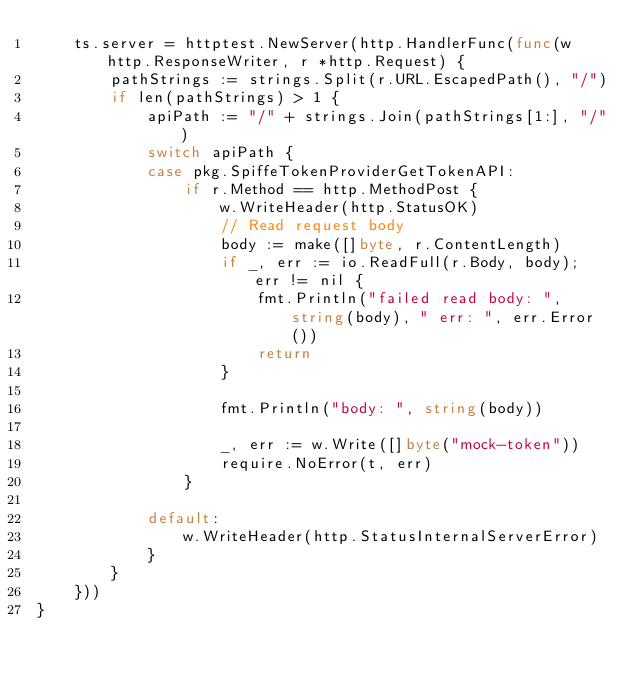<code> <loc_0><loc_0><loc_500><loc_500><_Go_>	ts.server = httptest.NewServer(http.HandlerFunc(func(w http.ResponseWriter, r *http.Request) {
		pathStrings := strings.Split(r.URL.EscapedPath(), "/")
		if len(pathStrings) > 1 {
			apiPath := "/" + strings.Join(pathStrings[1:], "/")
			switch apiPath {
			case pkg.SpiffeTokenProviderGetTokenAPI:
				if r.Method == http.MethodPost {
					w.WriteHeader(http.StatusOK)
					// Read request body
					body := make([]byte, r.ContentLength)
					if _, err := io.ReadFull(r.Body, body); err != nil {
						fmt.Println("failed read body: ", string(body), " err: ", err.Error())
						return
					}

					fmt.Println("body: ", string(body))

					_, err := w.Write([]byte("mock-token"))
					require.NoError(t, err)
				}

			default:
				w.WriteHeader(http.StatusInternalServerError)
			}
		}
	}))
}
</code> 